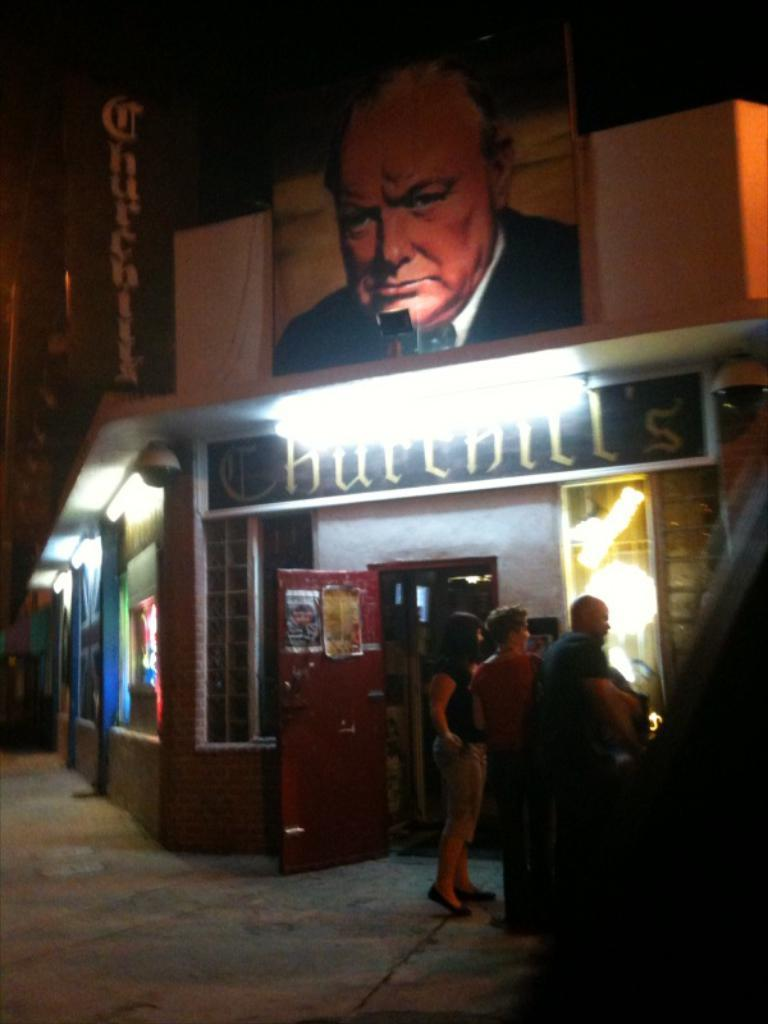How many people are present in the image? There are three persons standing in the image. What is the background of the image? There is a building in the image. What features can be observed on the building? The building has lights, a door, and boards. What type of prose is being recited by the son in the image? There is no son or prose present in the image. What type of wall is visible in the image? The image does not show any walls; it features a building with lights, a door, and boards. 